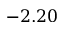Convert formula to latex. <formula><loc_0><loc_0><loc_500><loc_500>- 2 . 2 0</formula> 